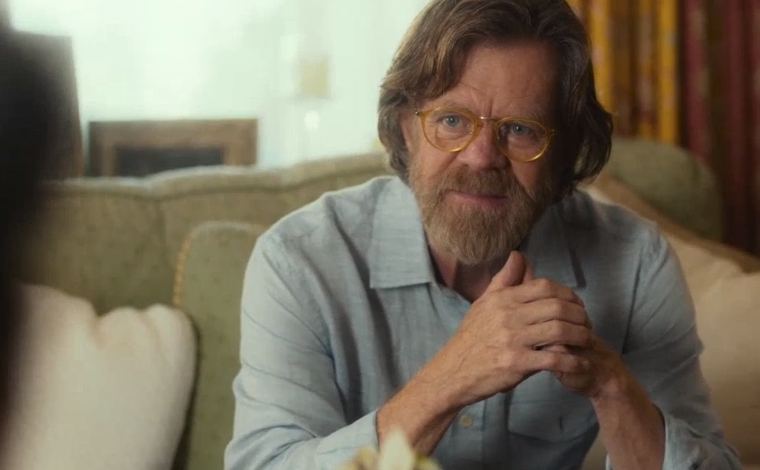What do you see happening in this image? In the image, a distinguished man is captured in a moment that suggests a thoughtful discussion. He is seated comfortably on a green armchair, his hands clasped together in front of him, indicative of an engaging conversation. He is wearing a casual blue shirt, sporting a beard and glasses which add an air of intellectual charm to his appearance. The setting is homely, featuring a cozy living room with a fireplace and patterned curtains in the background. The man appears deeply engrossed in a conversation with someone off-frame, further enhanced by the soft, warm lighting that underscores the intimate atmosphere of the scene. 